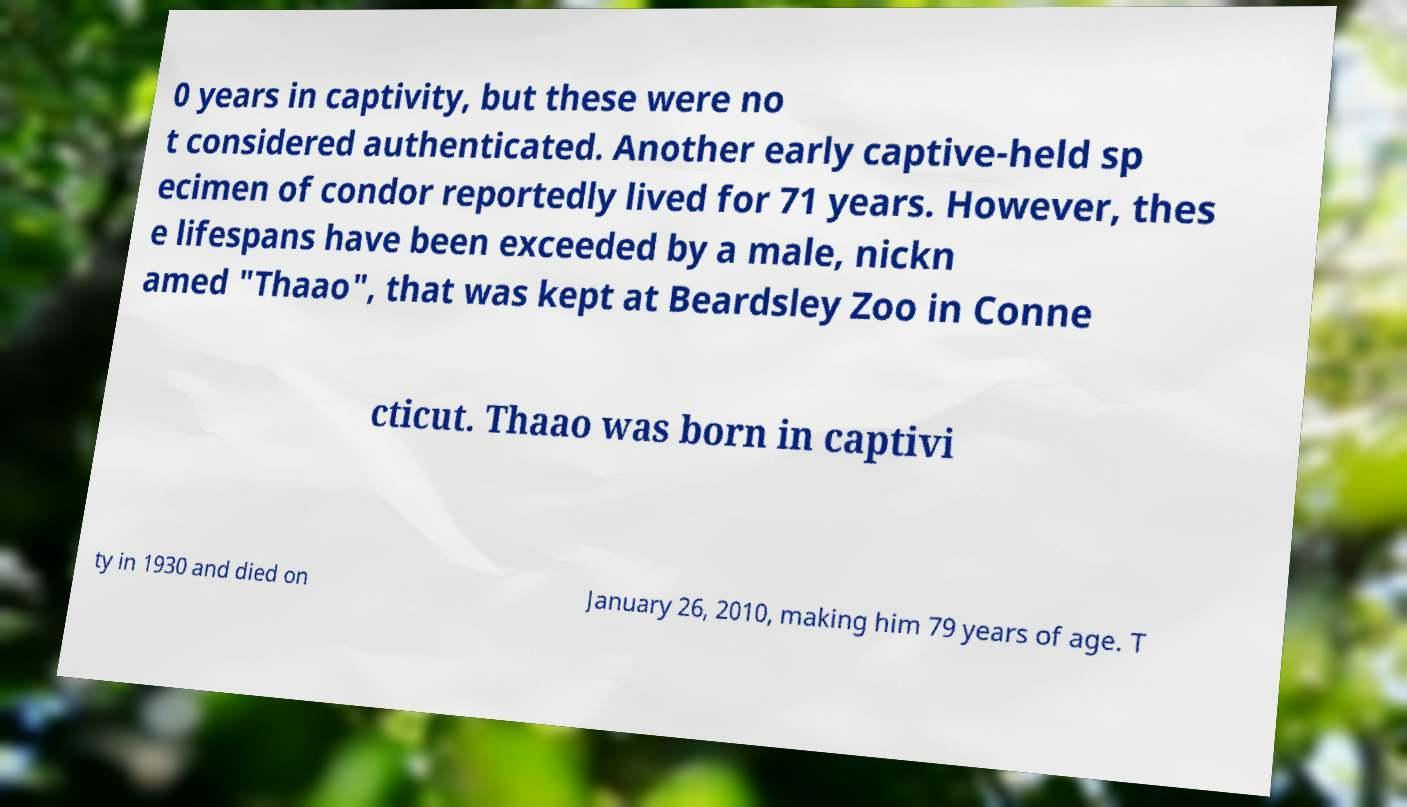I need the written content from this picture converted into text. Can you do that? 0 years in captivity, but these were no t considered authenticated. Another early captive-held sp ecimen of condor reportedly lived for 71 years. However, thes e lifespans have been exceeded by a male, nickn amed "Thaao", that was kept at Beardsley Zoo in Conne cticut. Thaao was born in captivi ty in 1930 and died on January 26, 2010, making him 79 years of age. T 